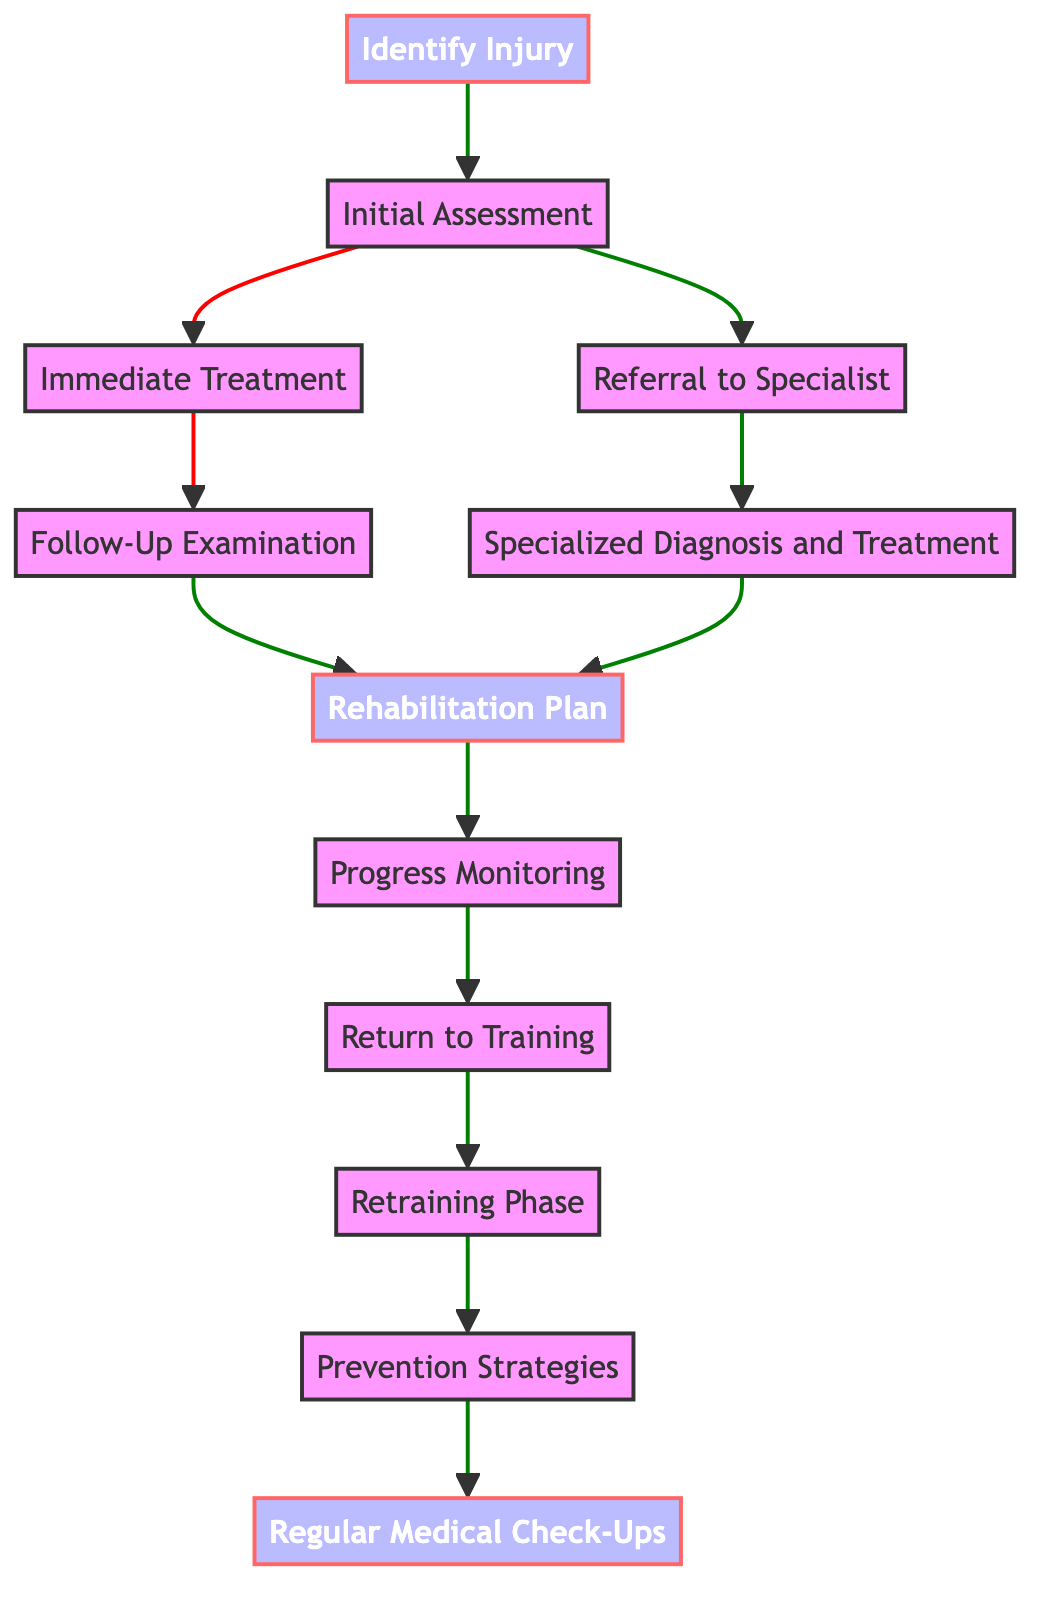What is the first step in the injury recovery process? The diagram indicates "Identify Injury" is the first step, as it is the first node in the flow chart and has arrows pointing to the next step.
Answer: Identify Injury How many nodes are there in the flowchart? By counting each distinct element in the diagram, there are a total of 12 nodes linked in the recovery process flow.
Answer: 12 Which process follows "Initial Assessment"? The "Initial Assessment" node has arrows pointing to two subsequent nodes: "Immediate Treatment" and "Referral to Specialist," so either may follow.
Answer: Immediate Treatment, Referral to Specialist What is the last step in the recovery process? The flowchart indicates that the final node is "Regular Medical Check-Ups," which has no further nodes connected to it, marking it as the endpoint of the recovery process.
Answer: Regular Medical Check-Ups Which node indicates a check-in for tracking recovery progress? The "Progress Monitoring" node is specifically designed for regular check-ins with the medical team, as described in the diagram.
Answer: Progress Monitoring What treatment method is applied immediately after the injury is identified? The "Immediate Treatment" step specifies that the R.I.C.E method (Rest, Ice, Compression, Elevation) is applied after the injury is identified.
Answer: R.I.C.E Between "Return to Training" and "Retraining Phase," which is the earlier node in the process? The diagram shows a direct flow from "Return to Training" leading into "Retraining Phase," thereby indicating that "Return to Training" occurs first in this sequence.
Answer: Return to Training Which step involves the development of a personalized recovery plan? The "Rehabilitation Plan" step is where a personalized recovery plan is developed, according to the flowchart.
Answer: Rehabilitation Plan What phase includes injury prevention exercises? The "Prevention Strategies" node specifically mentions implementing injury prevention exercises, making it the correct phase for this process.
Answer: Prevention Strategies 